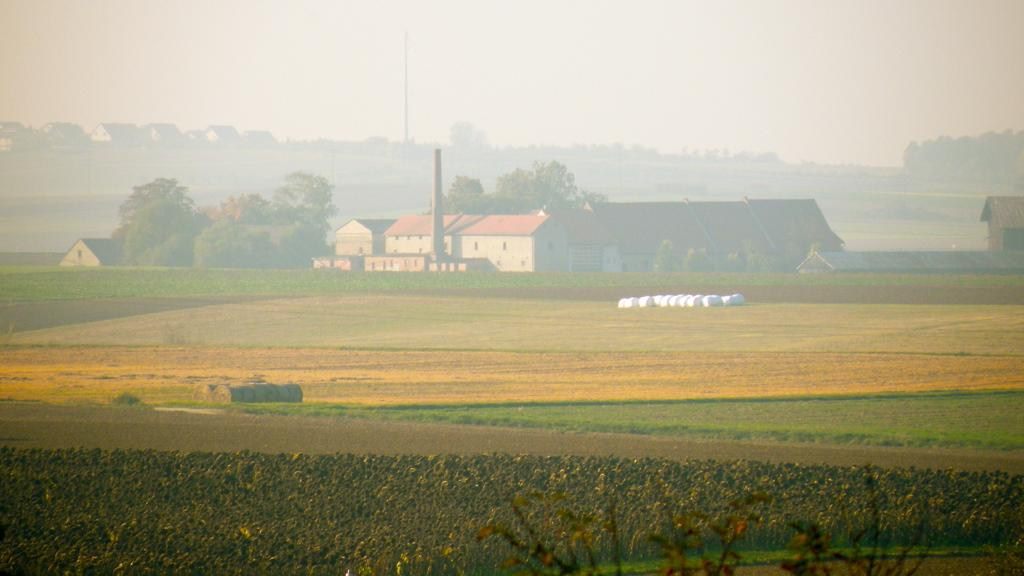What type of vegetation is present on the front side of the image? There are plants and grass on the front side of the image. What structures can be seen in the background of the image? There are houses and trees in the background of the image. What part of the sky is visible in the image? The sky is visible in the background of the image. Where is the mailbox located in the image? There is no mailbox present in the image. How does the comfort of the grass affect the overall mood of the image? The comfort of the grass is not mentioned in the provided facts, so it cannot be determined how it might affect the overall mood of the image. 